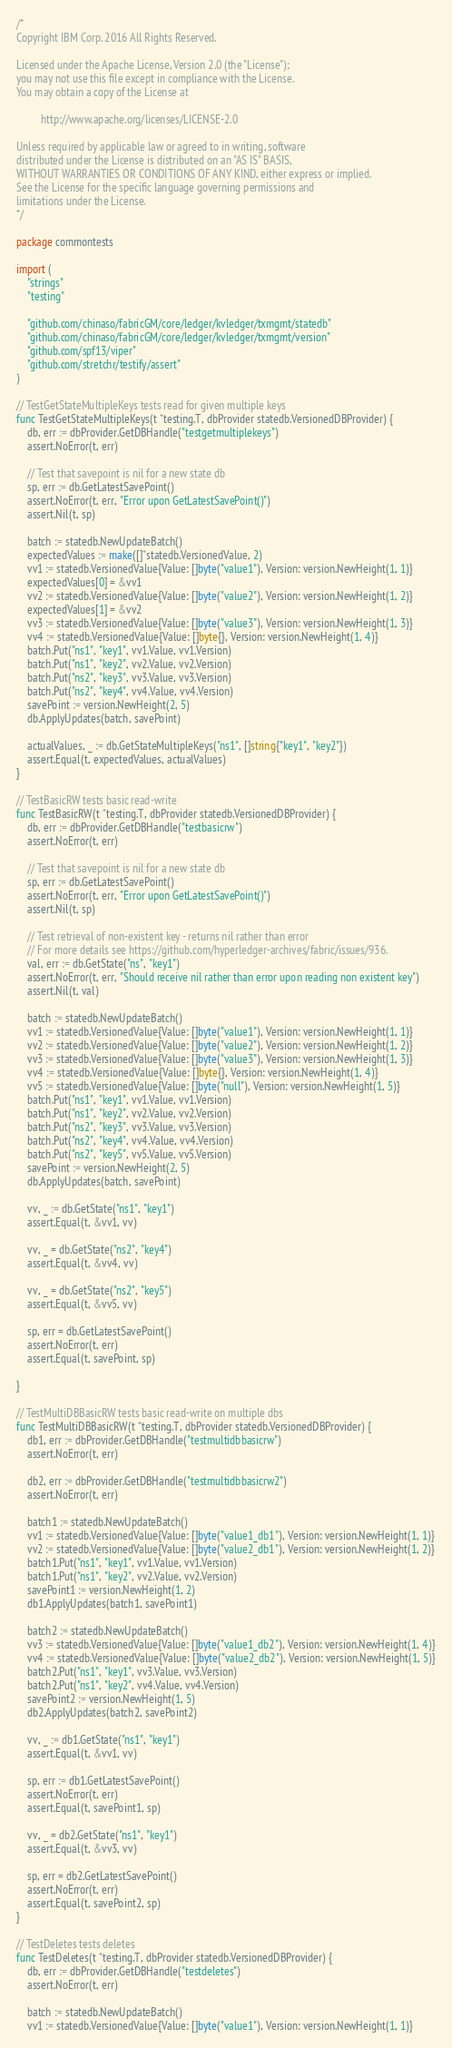<code> <loc_0><loc_0><loc_500><loc_500><_Go_>/*
Copyright IBM Corp. 2016 All Rights Reserved.

Licensed under the Apache License, Version 2.0 (the "License");
you may not use this file except in compliance with the License.
You may obtain a copy of the License at

		 http://www.apache.org/licenses/LICENSE-2.0

Unless required by applicable law or agreed to in writing, software
distributed under the License is distributed on an "AS IS" BASIS,
WITHOUT WARRANTIES OR CONDITIONS OF ANY KIND, either express or implied.
See the License for the specific language governing permissions and
limitations under the License.
*/

package commontests

import (
	"strings"
	"testing"

	"github.com/chinaso/fabricGM/core/ledger/kvledger/txmgmt/statedb"
	"github.com/chinaso/fabricGM/core/ledger/kvledger/txmgmt/version"
	"github.com/spf13/viper"
	"github.com/stretchr/testify/assert"
)

// TestGetStateMultipleKeys tests read for given multiple keys
func TestGetStateMultipleKeys(t *testing.T, dbProvider statedb.VersionedDBProvider) {
	db, err := dbProvider.GetDBHandle("testgetmultiplekeys")
	assert.NoError(t, err)

	// Test that savepoint is nil for a new state db
	sp, err := db.GetLatestSavePoint()
	assert.NoError(t, err, "Error upon GetLatestSavePoint()")
	assert.Nil(t, sp)

	batch := statedb.NewUpdateBatch()
	expectedValues := make([]*statedb.VersionedValue, 2)
	vv1 := statedb.VersionedValue{Value: []byte("value1"), Version: version.NewHeight(1, 1)}
	expectedValues[0] = &vv1
	vv2 := statedb.VersionedValue{Value: []byte("value2"), Version: version.NewHeight(1, 2)}
	expectedValues[1] = &vv2
	vv3 := statedb.VersionedValue{Value: []byte("value3"), Version: version.NewHeight(1, 3)}
	vv4 := statedb.VersionedValue{Value: []byte{}, Version: version.NewHeight(1, 4)}
	batch.Put("ns1", "key1", vv1.Value, vv1.Version)
	batch.Put("ns1", "key2", vv2.Value, vv2.Version)
	batch.Put("ns2", "key3", vv3.Value, vv3.Version)
	batch.Put("ns2", "key4", vv4.Value, vv4.Version)
	savePoint := version.NewHeight(2, 5)
	db.ApplyUpdates(batch, savePoint)

	actualValues, _ := db.GetStateMultipleKeys("ns1", []string{"key1", "key2"})
	assert.Equal(t, expectedValues, actualValues)
}

// TestBasicRW tests basic read-write
func TestBasicRW(t *testing.T, dbProvider statedb.VersionedDBProvider) {
	db, err := dbProvider.GetDBHandle("testbasicrw")
	assert.NoError(t, err)

	// Test that savepoint is nil for a new state db
	sp, err := db.GetLatestSavePoint()
	assert.NoError(t, err, "Error upon GetLatestSavePoint()")
	assert.Nil(t, sp)

	// Test retrieval of non-existent key - returns nil rather than error
	// For more details see https://github.com/hyperledger-archives/fabric/issues/936.
	val, err := db.GetState("ns", "key1")
	assert.NoError(t, err, "Should receive nil rather than error upon reading non existent key")
	assert.Nil(t, val)

	batch := statedb.NewUpdateBatch()
	vv1 := statedb.VersionedValue{Value: []byte("value1"), Version: version.NewHeight(1, 1)}
	vv2 := statedb.VersionedValue{Value: []byte("value2"), Version: version.NewHeight(1, 2)}
	vv3 := statedb.VersionedValue{Value: []byte("value3"), Version: version.NewHeight(1, 3)}
	vv4 := statedb.VersionedValue{Value: []byte{}, Version: version.NewHeight(1, 4)}
	vv5 := statedb.VersionedValue{Value: []byte("null"), Version: version.NewHeight(1, 5)}
	batch.Put("ns1", "key1", vv1.Value, vv1.Version)
	batch.Put("ns1", "key2", vv2.Value, vv2.Version)
	batch.Put("ns2", "key3", vv3.Value, vv3.Version)
	batch.Put("ns2", "key4", vv4.Value, vv4.Version)
	batch.Put("ns2", "key5", vv5.Value, vv5.Version)
	savePoint := version.NewHeight(2, 5)
	db.ApplyUpdates(batch, savePoint)

	vv, _ := db.GetState("ns1", "key1")
	assert.Equal(t, &vv1, vv)

	vv, _ = db.GetState("ns2", "key4")
	assert.Equal(t, &vv4, vv)

	vv, _ = db.GetState("ns2", "key5")
	assert.Equal(t, &vv5, vv)

	sp, err = db.GetLatestSavePoint()
	assert.NoError(t, err)
	assert.Equal(t, savePoint, sp)

}

// TestMultiDBBasicRW tests basic read-write on multiple dbs
func TestMultiDBBasicRW(t *testing.T, dbProvider statedb.VersionedDBProvider) {
	db1, err := dbProvider.GetDBHandle("testmultidbbasicrw")
	assert.NoError(t, err)

	db2, err := dbProvider.GetDBHandle("testmultidbbasicrw2")
	assert.NoError(t, err)

	batch1 := statedb.NewUpdateBatch()
	vv1 := statedb.VersionedValue{Value: []byte("value1_db1"), Version: version.NewHeight(1, 1)}
	vv2 := statedb.VersionedValue{Value: []byte("value2_db1"), Version: version.NewHeight(1, 2)}
	batch1.Put("ns1", "key1", vv1.Value, vv1.Version)
	batch1.Put("ns1", "key2", vv2.Value, vv2.Version)
	savePoint1 := version.NewHeight(1, 2)
	db1.ApplyUpdates(batch1, savePoint1)

	batch2 := statedb.NewUpdateBatch()
	vv3 := statedb.VersionedValue{Value: []byte("value1_db2"), Version: version.NewHeight(1, 4)}
	vv4 := statedb.VersionedValue{Value: []byte("value2_db2"), Version: version.NewHeight(1, 5)}
	batch2.Put("ns1", "key1", vv3.Value, vv3.Version)
	batch2.Put("ns1", "key2", vv4.Value, vv4.Version)
	savePoint2 := version.NewHeight(1, 5)
	db2.ApplyUpdates(batch2, savePoint2)

	vv, _ := db1.GetState("ns1", "key1")
	assert.Equal(t, &vv1, vv)

	sp, err := db1.GetLatestSavePoint()
	assert.NoError(t, err)
	assert.Equal(t, savePoint1, sp)

	vv, _ = db2.GetState("ns1", "key1")
	assert.Equal(t, &vv3, vv)

	sp, err = db2.GetLatestSavePoint()
	assert.NoError(t, err)
	assert.Equal(t, savePoint2, sp)
}

// TestDeletes tests deletes
func TestDeletes(t *testing.T, dbProvider statedb.VersionedDBProvider) {
	db, err := dbProvider.GetDBHandle("testdeletes")
	assert.NoError(t, err)

	batch := statedb.NewUpdateBatch()
	vv1 := statedb.VersionedValue{Value: []byte("value1"), Version: version.NewHeight(1, 1)}</code> 